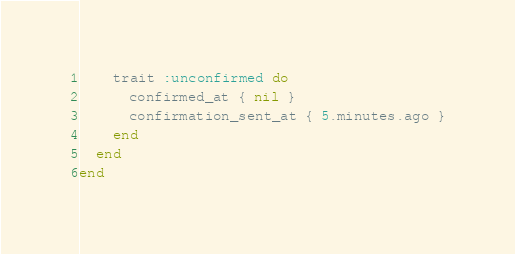<code> <loc_0><loc_0><loc_500><loc_500><_Ruby_>
    trait :unconfirmed do
      confirmed_at { nil }
      confirmation_sent_at { 5.minutes.ago }
    end
  end
end
</code> 